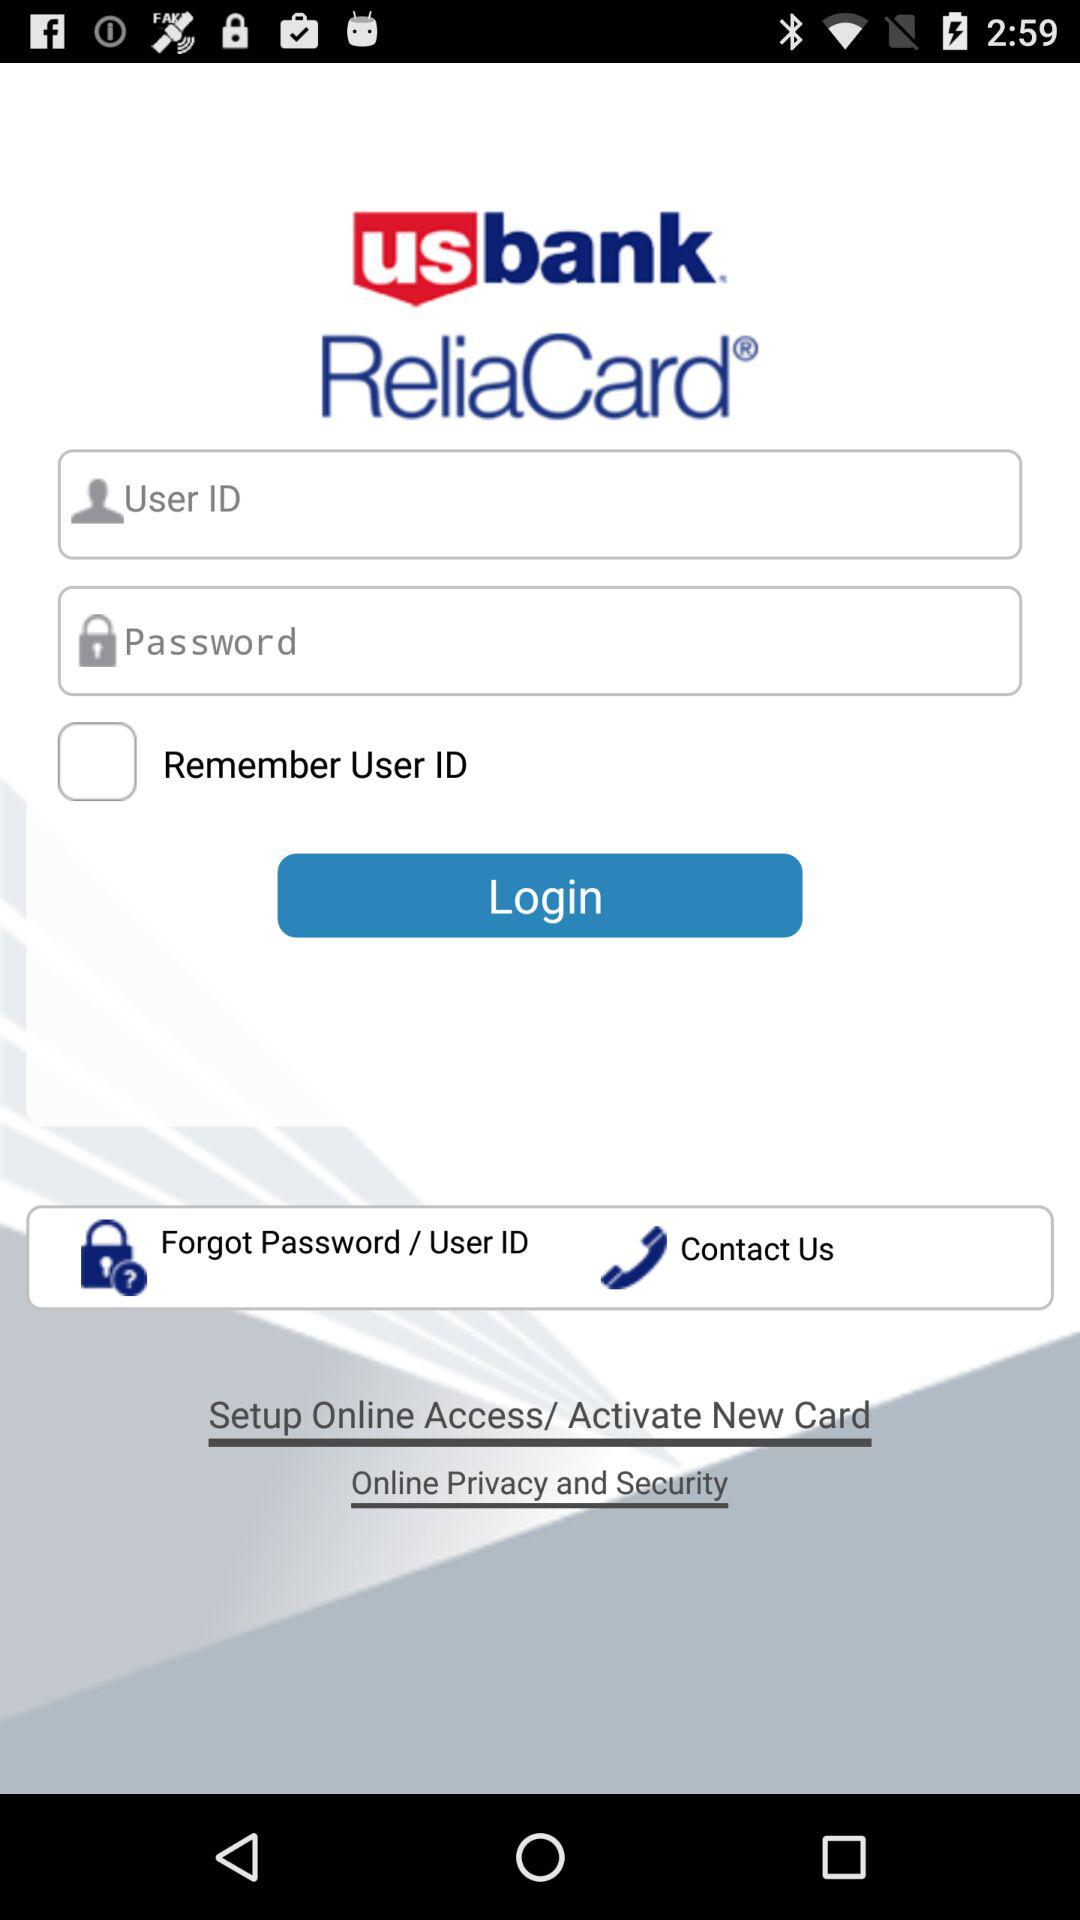What is the status of "Remember User ID"? The status is "off". 